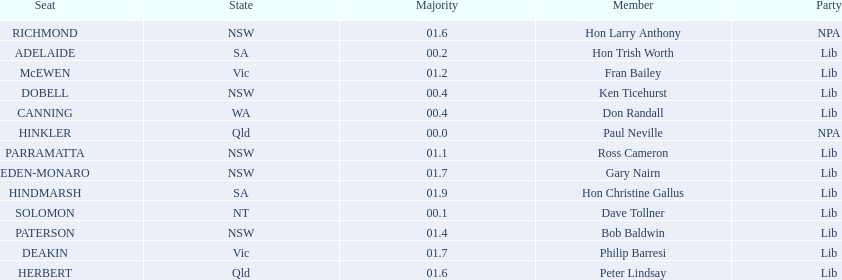Could you parse the entire table? {'header': ['Seat', 'State', 'Majority', 'Member', 'Party'], 'rows': [['RICHMOND', 'NSW', '01.6', 'Hon Larry Anthony', 'NPA'], ['ADELAIDE', 'SA', '00.2', 'Hon Trish Worth', 'Lib'], ['McEWEN', 'Vic', '01.2', 'Fran Bailey', 'Lib'], ['DOBELL', 'NSW', '00.4', 'Ken Ticehurst', 'Lib'], ['CANNING', 'WA', '00.4', 'Don Randall', 'Lib'], ['HINKLER', 'Qld', '00.0', 'Paul Neville', 'NPA'], ['PARRAMATTA', 'NSW', '01.1', 'Ross Cameron', 'Lib'], ['EDEN-MONARO', 'NSW', '01.7', 'Gary Nairn', 'Lib'], ['HINDMARSH', 'SA', '01.9', 'Hon Christine Gallus', 'Lib'], ['SOLOMON', 'NT', '00.1', 'Dave Tollner', 'Lib'], ['PATERSON', 'NSW', '01.4', 'Bob Baldwin', 'Lib'], ['DEAKIN', 'Vic', '01.7', 'Philip Barresi', 'Lib'], ['HERBERT', 'Qld', '01.6', 'Peter Lindsay', 'Lib']]} What member comes next after hon trish worth? Don Randall. 